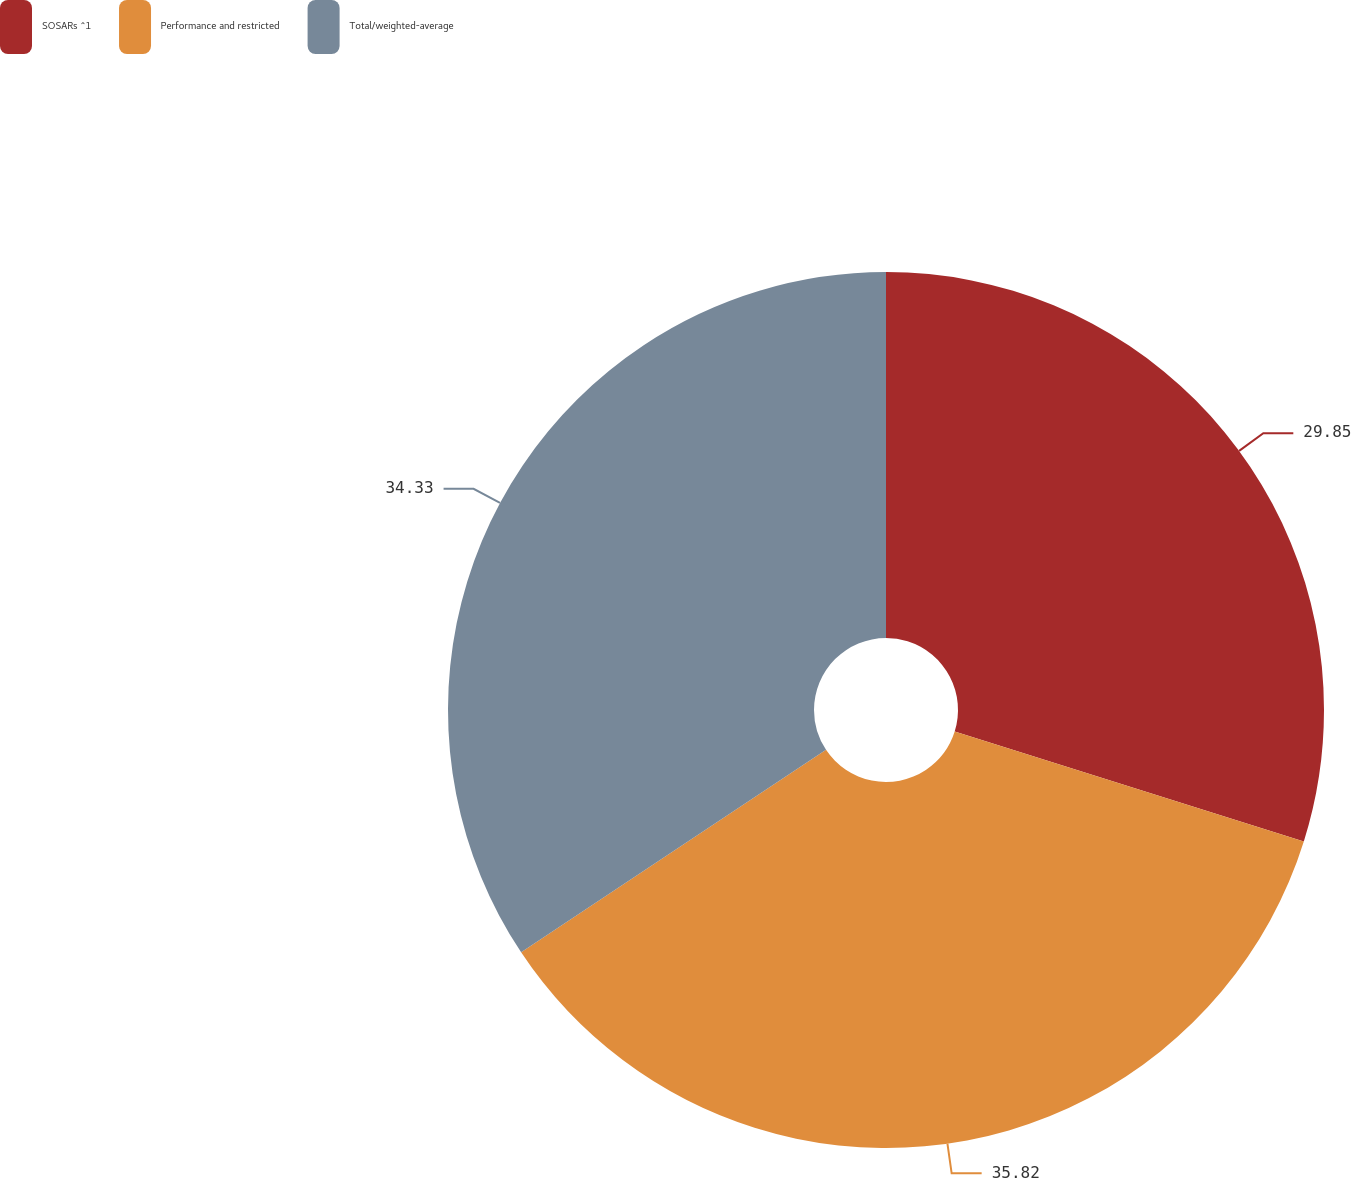Convert chart to OTSL. <chart><loc_0><loc_0><loc_500><loc_500><pie_chart><fcel>SOSARs ^1<fcel>Performance and restricted<fcel>Total/weighted-average<nl><fcel>29.85%<fcel>35.82%<fcel>34.33%<nl></chart> 